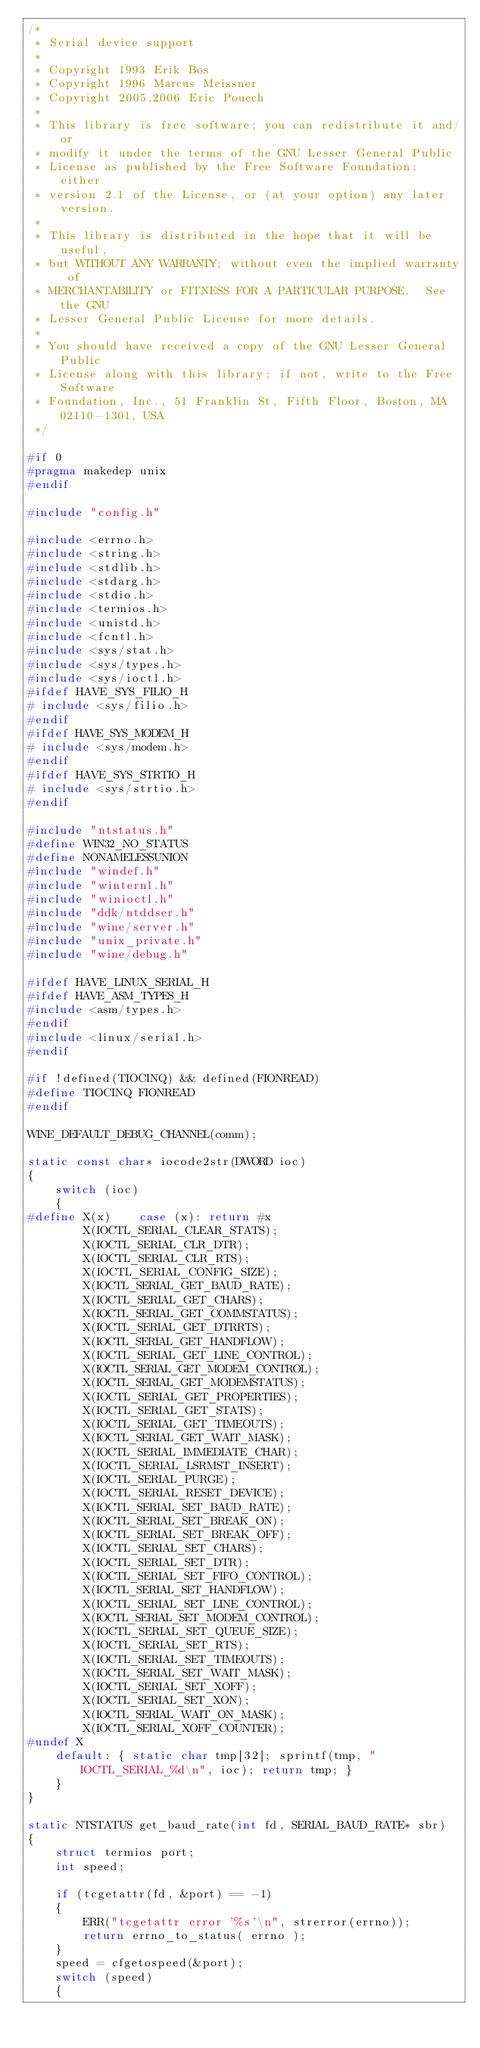<code> <loc_0><loc_0><loc_500><loc_500><_C_>/*
 * Serial device support
 *
 * Copyright 1993 Erik Bos
 * Copyright 1996 Marcus Meissner
 * Copyright 2005,2006 Eric Pouech
 *
 * This library is free software; you can redistribute it and/or
 * modify it under the terms of the GNU Lesser General Public
 * License as published by the Free Software Foundation; either
 * version 2.1 of the License, or (at your option) any later version.
 *
 * This library is distributed in the hope that it will be useful,
 * but WITHOUT ANY WARRANTY; without even the implied warranty of
 * MERCHANTABILITY or FITNESS FOR A PARTICULAR PURPOSE.  See the GNU
 * Lesser General Public License for more details.
 *
 * You should have received a copy of the GNU Lesser General Public
 * License along with this library; if not, write to the Free Software
 * Foundation, Inc., 51 Franklin St, Fifth Floor, Boston, MA 02110-1301, USA
 */

#if 0
#pragma makedep unix
#endif

#include "config.h"

#include <errno.h>
#include <string.h>
#include <stdlib.h>
#include <stdarg.h>
#include <stdio.h>
#include <termios.h>
#include <unistd.h>
#include <fcntl.h>
#include <sys/stat.h>
#include <sys/types.h>
#include <sys/ioctl.h>
#ifdef HAVE_SYS_FILIO_H
# include <sys/filio.h>
#endif
#ifdef HAVE_SYS_MODEM_H
# include <sys/modem.h>
#endif
#ifdef HAVE_SYS_STRTIO_H
# include <sys/strtio.h>
#endif

#include "ntstatus.h"
#define WIN32_NO_STATUS
#define NONAMELESSUNION
#include "windef.h"
#include "winternl.h"
#include "winioctl.h"
#include "ddk/ntddser.h"
#include "wine/server.h"
#include "unix_private.h"
#include "wine/debug.h"

#ifdef HAVE_LINUX_SERIAL_H
#ifdef HAVE_ASM_TYPES_H
#include <asm/types.h>
#endif
#include <linux/serial.h>
#endif

#if !defined(TIOCINQ) && defined(FIONREAD)
#define	TIOCINQ FIONREAD
#endif

WINE_DEFAULT_DEBUG_CHANNEL(comm);

static const char* iocode2str(DWORD ioc)
{
    switch (ioc)
    {
#define X(x)    case (x): return #x
        X(IOCTL_SERIAL_CLEAR_STATS);
        X(IOCTL_SERIAL_CLR_DTR);
        X(IOCTL_SERIAL_CLR_RTS);
        X(IOCTL_SERIAL_CONFIG_SIZE);
        X(IOCTL_SERIAL_GET_BAUD_RATE);
        X(IOCTL_SERIAL_GET_CHARS);
        X(IOCTL_SERIAL_GET_COMMSTATUS);
        X(IOCTL_SERIAL_GET_DTRRTS);
        X(IOCTL_SERIAL_GET_HANDFLOW);
        X(IOCTL_SERIAL_GET_LINE_CONTROL);
        X(IOCTL_SERIAL_GET_MODEM_CONTROL);
        X(IOCTL_SERIAL_GET_MODEMSTATUS);
        X(IOCTL_SERIAL_GET_PROPERTIES);
        X(IOCTL_SERIAL_GET_STATS);
        X(IOCTL_SERIAL_GET_TIMEOUTS);
        X(IOCTL_SERIAL_GET_WAIT_MASK);
        X(IOCTL_SERIAL_IMMEDIATE_CHAR);
        X(IOCTL_SERIAL_LSRMST_INSERT);
        X(IOCTL_SERIAL_PURGE);
        X(IOCTL_SERIAL_RESET_DEVICE);
        X(IOCTL_SERIAL_SET_BAUD_RATE);
        X(IOCTL_SERIAL_SET_BREAK_ON);
        X(IOCTL_SERIAL_SET_BREAK_OFF);
        X(IOCTL_SERIAL_SET_CHARS);
        X(IOCTL_SERIAL_SET_DTR);
        X(IOCTL_SERIAL_SET_FIFO_CONTROL);
        X(IOCTL_SERIAL_SET_HANDFLOW);
        X(IOCTL_SERIAL_SET_LINE_CONTROL);
        X(IOCTL_SERIAL_SET_MODEM_CONTROL);
        X(IOCTL_SERIAL_SET_QUEUE_SIZE);
        X(IOCTL_SERIAL_SET_RTS);
        X(IOCTL_SERIAL_SET_TIMEOUTS);
        X(IOCTL_SERIAL_SET_WAIT_MASK);
        X(IOCTL_SERIAL_SET_XOFF);
        X(IOCTL_SERIAL_SET_XON);
        X(IOCTL_SERIAL_WAIT_ON_MASK);
        X(IOCTL_SERIAL_XOFF_COUNTER);
#undef X
    default: { static char tmp[32]; sprintf(tmp, "IOCTL_SERIAL_%d\n", ioc); return tmp; }
    }
}

static NTSTATUS get_baud_rate(int fd, SERIAL_BAUD_RATE* sbr)
{
    struct termios port;
    int speed;

    if (tcgetattr(fd, &port) == -1)
    {
        ERR("tcgetattr error '%s'\n", strerror(errno));
        return errno_to_status( errno );
    }
    speed = cfgetospeed(&port);
    switch (speed)
    {</code> 